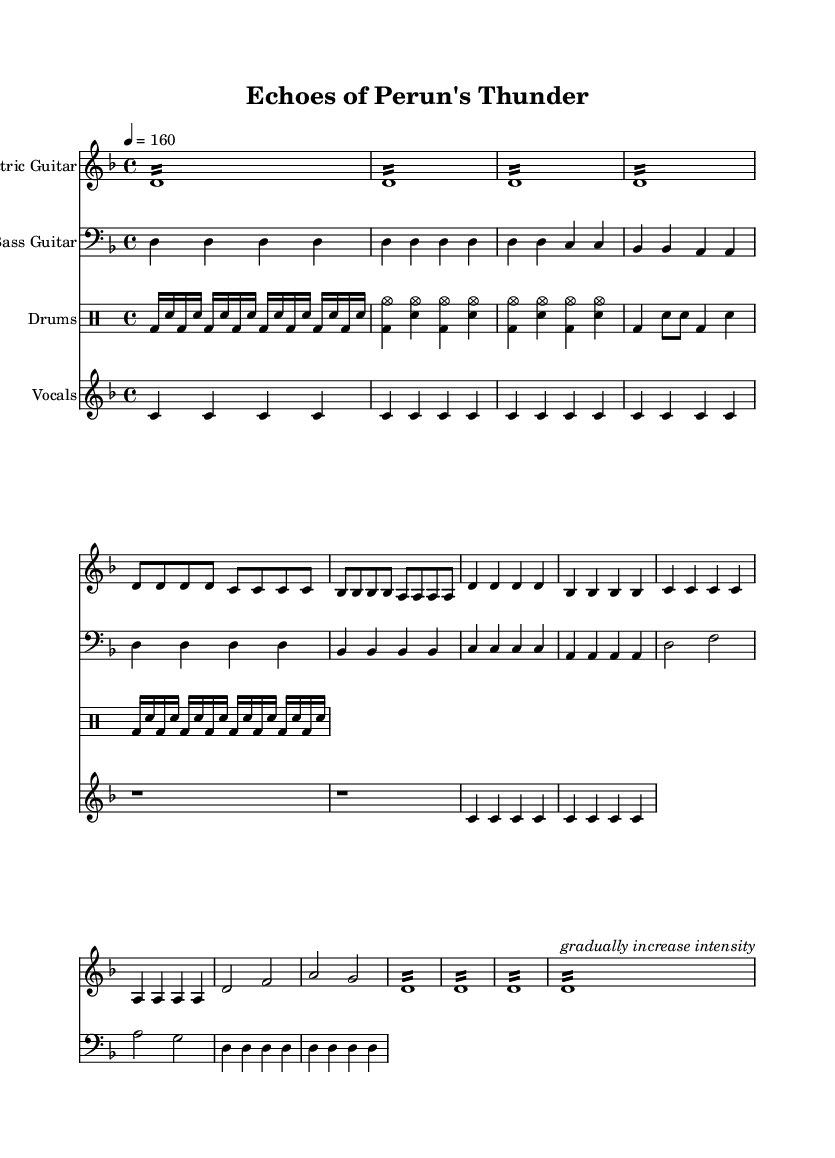What is the key signature of this music? The key signature is indicated at the beginning of the score, showing two flats, which corresponds to D minor.
Answer: D minor What is the time signature of this piece? The time signature is visible at the beginning of the score, showing a 4 over 4, meaning there are four beats per measure.
Answer: 4/4 What is the tempo marking for this music? The tempo is indicated at the start of the piece as a quarter note equals 160 beats per minute, which sets the speed of the music.
Answer: 160 How many sections are there in the song structure? By analyzing the distinct parts labeled in the score, we can identify an Intro, Verse, Chorus, Bridge, and Outro, making a total of five sections.
Answer: 5 Which instrument primarily plays the melody in the chorus? By looking at the score, the Electric Guitar is indicated to play the main melodic lines during the chorus section, as it has the primary notes marked there.
Answer: Electric Guitar In which section does the intensity increase with tremolo? The score indicates tremolo markings specifically in the Outro section, which directs the performer to emphasize this part as the intensity rises.
Answer: Outro What folklore influence is suggested in the title of the piece? The title "Echoes of Perun's Thunder" refers to Perun, a Slavic god of thunder and lightning, linking the music to Slavic paganism and folklore themes.
Answer: Perun 